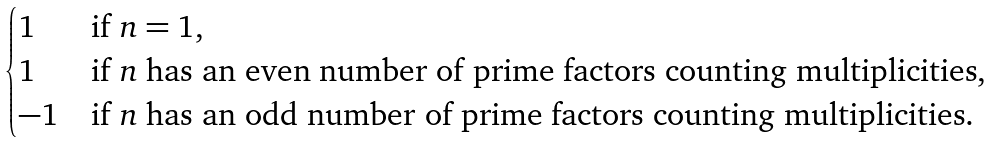Convert formula to latex. <formula><loc_0><loc_0><loc_500><loc_500>\begin{cases} 1 & \text {if $n=1$,} \\ 1 & \text {if $n$ has an even number of prime factors counting multiplicities,} \\ - 1 & \text {if $n$ has an odd number of prime factors counting multiplicities.} \end{cases}</formula> 